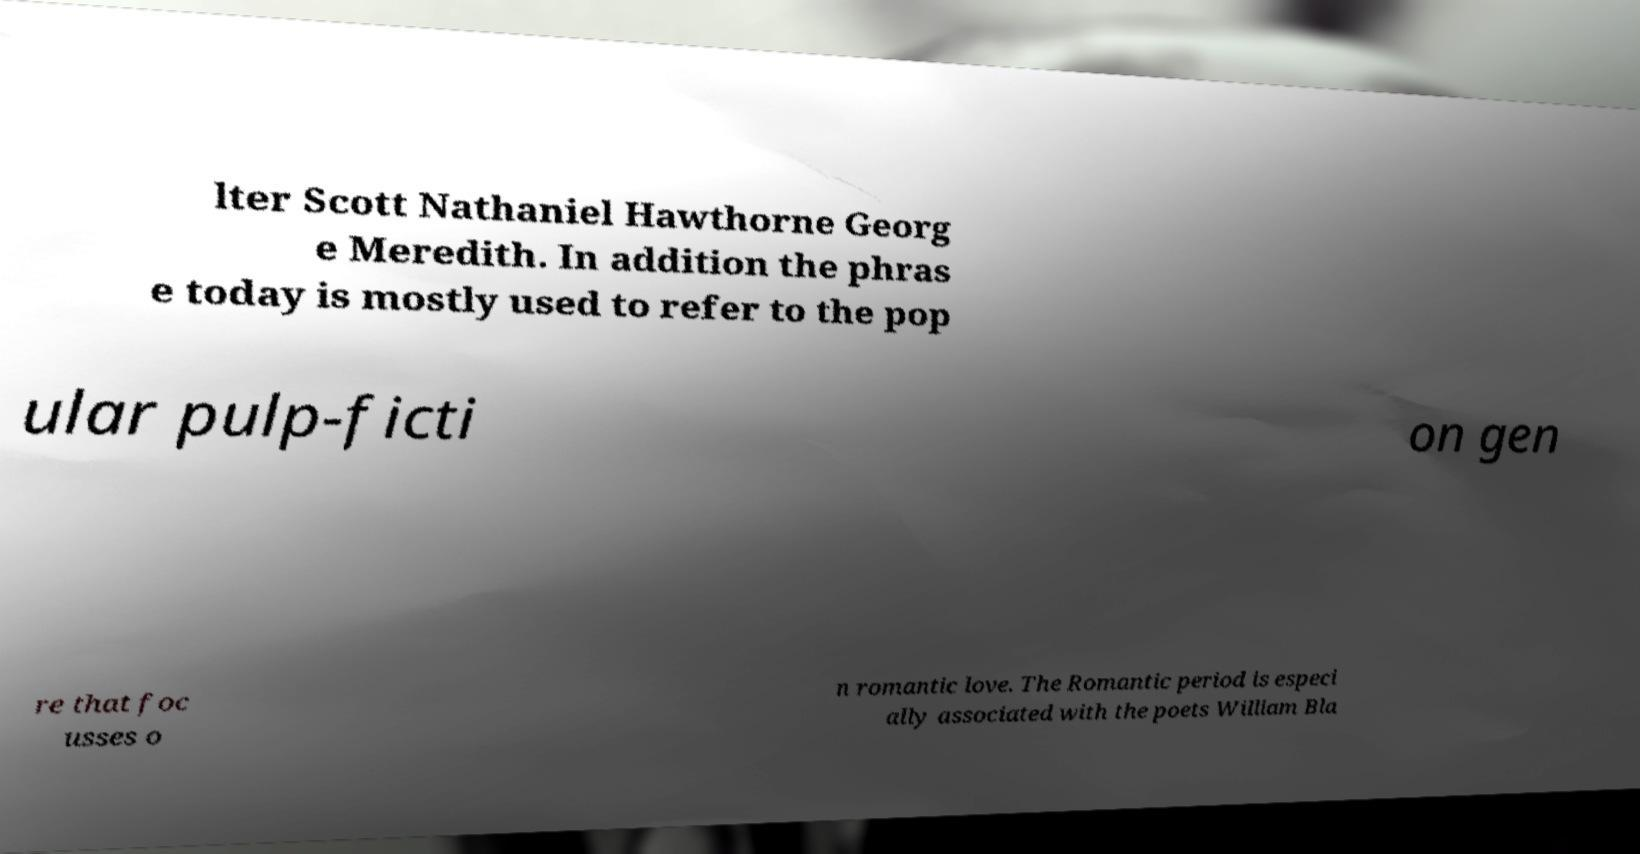Could you extract and type out the text from this image? lter Scott Nathaniel Hawthorne Georg e Meredith. In addition the phras e today is mostly used to refer to the pop ular pulp-ficti on gen re that foc usses o n romantic love. The Romantic period is especi ally associated with the poets William Bla 